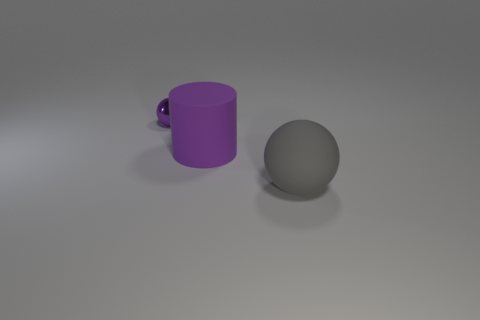Add 3 metallic spheres. How many objects exist? 6 Subtract all spheres. How many objects are left? 1 Add 1 big purple things. How many big purple things are left? 2 Add 1 purple spheres. How many purple spheres exist? 2 Subtract 0 red spheres. How many objects are left? 3 Subtract all small yellow cylinders. Subtract all balls. How many objects are left? 1 